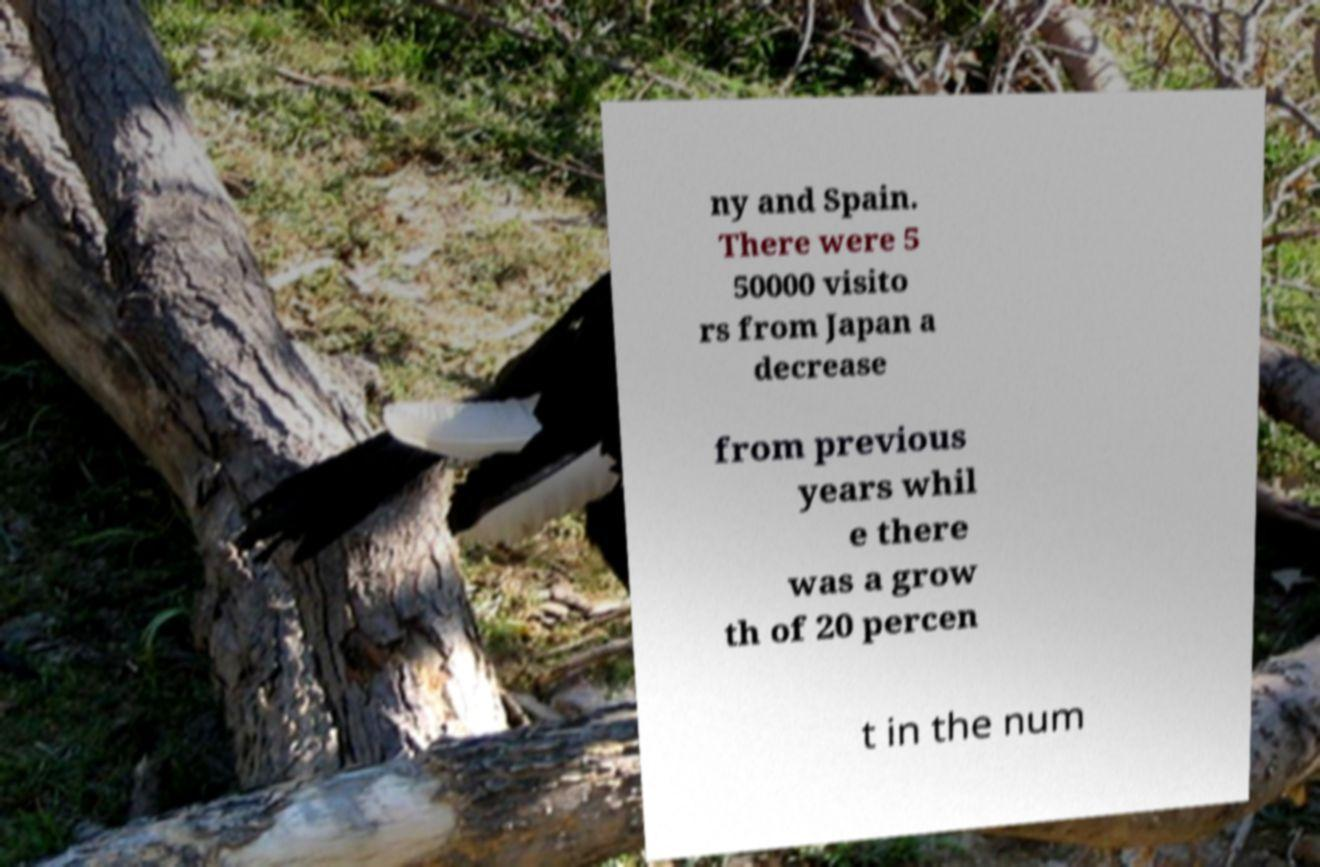For documentation purposes, I need the text within this image transcribed. Could you provide that? ny and Spain. There were 5 50000 visito rs from Japan a decrease from previous years whil e there was a grow th of 20 percen t in the num 